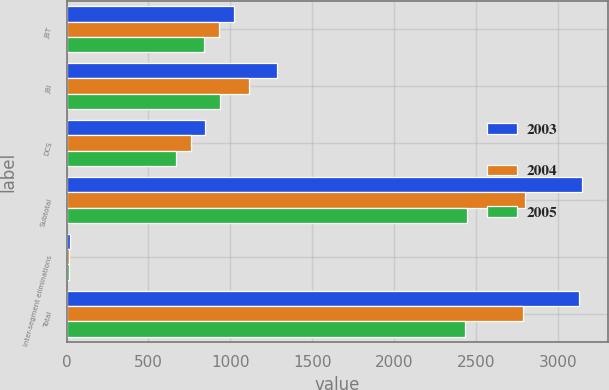Convert chart. <chart><loc_0><loc_0><loc_500><loc_500><stacked_bar_chart><ecel><fcel>JBT<fcel>JBI<fcel>DCS<fcel>Subtotal<fcel>Inter-segment eliminations<fcel>Total<nl><fcel>2003<fcel>1020<fcel>1284<fcel>844<fcel>3148<fcel>20<fcel>3128<nl><fcel>2004<fcel>928<fcel>1115<fcel>760<fcel>2803<fcel>17<fcel>2786<nl><fcel>2005<fcel>841<fcel>936<fcel>671<fcel>2448<fcel>15<fcel>2433<nl></chart> 